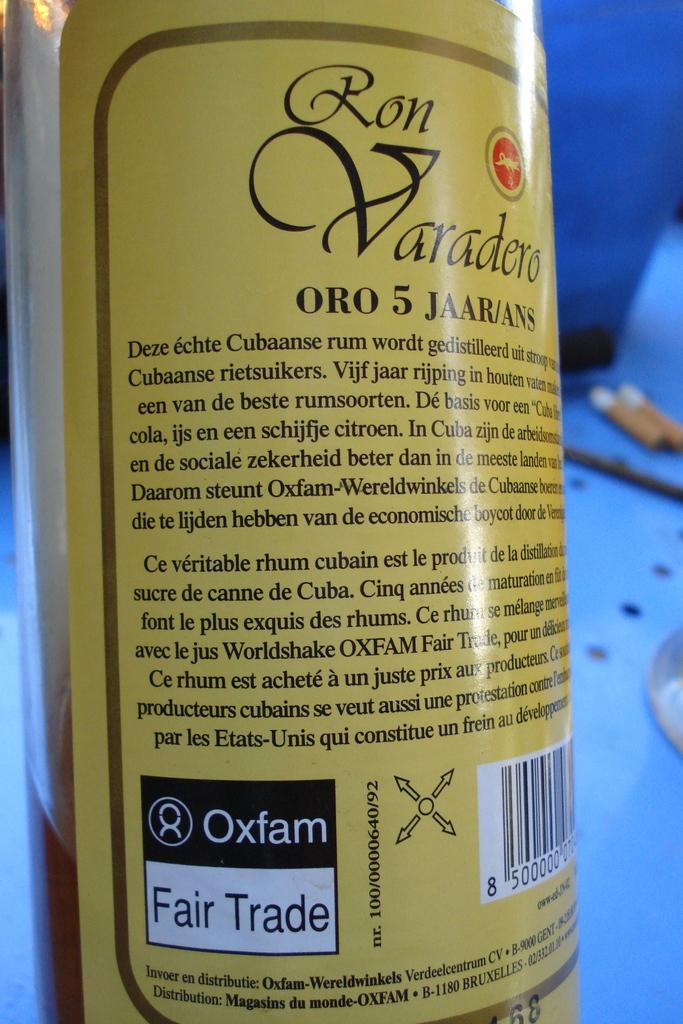Is it fair trade?
Your answer should be very brief. Yes. 